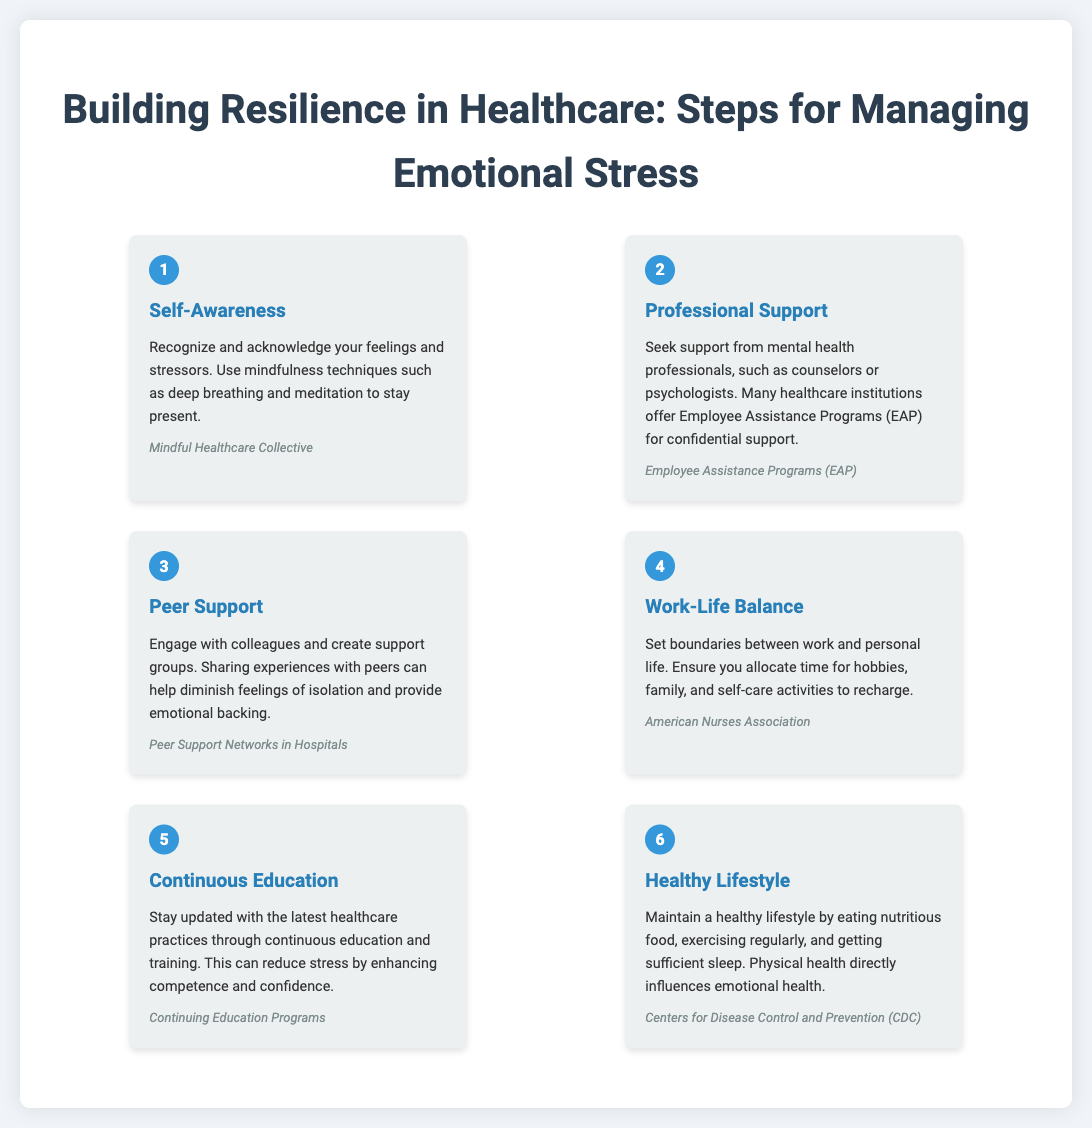What is the first step for managing emotional stress? The first step mentioned in the infographic is "Self-Awareness," which involves recognizing and acknowledging feelings and stressors.
Answer: Self-Awareness How many steps are there in the infographic? The infographic outlines a total of six steps for managing emotional stress.
Answer: 6 What professional support is suggested in step 2? Step 2 encourages seeking support from mental health professionals, specifically mentioning counselors or psychologists.
Answer: Counselors or psychologists Which organization is associated with work-life balance? The organization mentioned in the work-life balance step is the American Nurses Association.
Answer: American Nurses Association What is a key component of a healthy lifestyle according to step 6? Step 6 emphasizes the importance of maintaining a healthy lifestyle, which includes eating nutritious food.
Answer: Eating nutritious food Why is continuous education important in healthcare? Continuous education is important because it enhances competence and confidence, which can reduce stress.
Answer: Enhances competence and confidence What entity is cited for self-care activities in step 4? The entity referred to for promoting self-care activities is the American Nurses Association.
Answer: American Nurses Association 